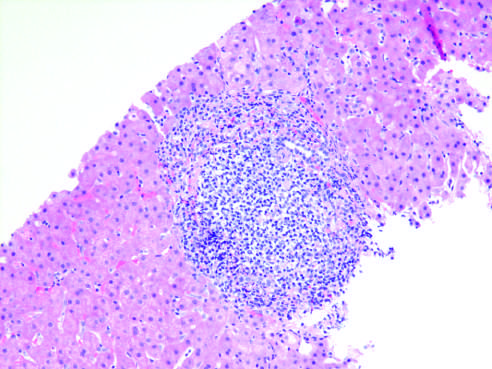what did chronic viral hepatitis due to hcv show?
Answer the question using a single word or phrase. Characteristic portal tract expansion by a dense lymphoid infiltrate 